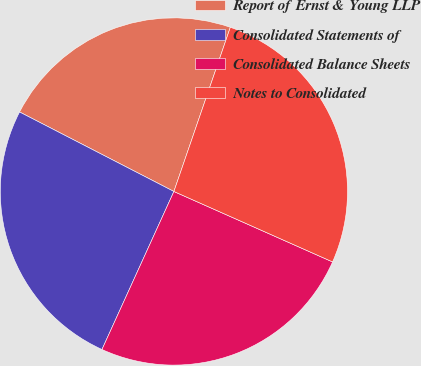<chart> <loc_0><loc_0><loc_500><loc_500><pie_chart><fcel>Report of Ernst & Young LLP<fcel>Consolidated Statements of<fcel>Consolidated Balance Sheets<fcel>Notes to Consolidated<nl><fcel>22.7%<fcel>25.77%<fcel>25.15%<fcel>26.38%<nl></chart> 